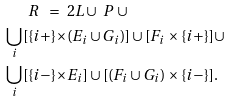Convert formula to latex. <formula><loc_0><loc_0><loc_500><loc_500>R \ = \ & 2 L \cup \ P \ \cup \\ \bigcup _ { i } [ \{ i + \} \times & ( E _ { i } \cup G _ { i } ) ] \cup [ F _ { i } \times \{ i + \} ] \cup \\ \bigcup _ { i } [ \{ i - \} \times & E _ { i } ] \cup [ ( F _ { i } \cup G _ { i } ) \times \{ i - \} ] .</formula> 